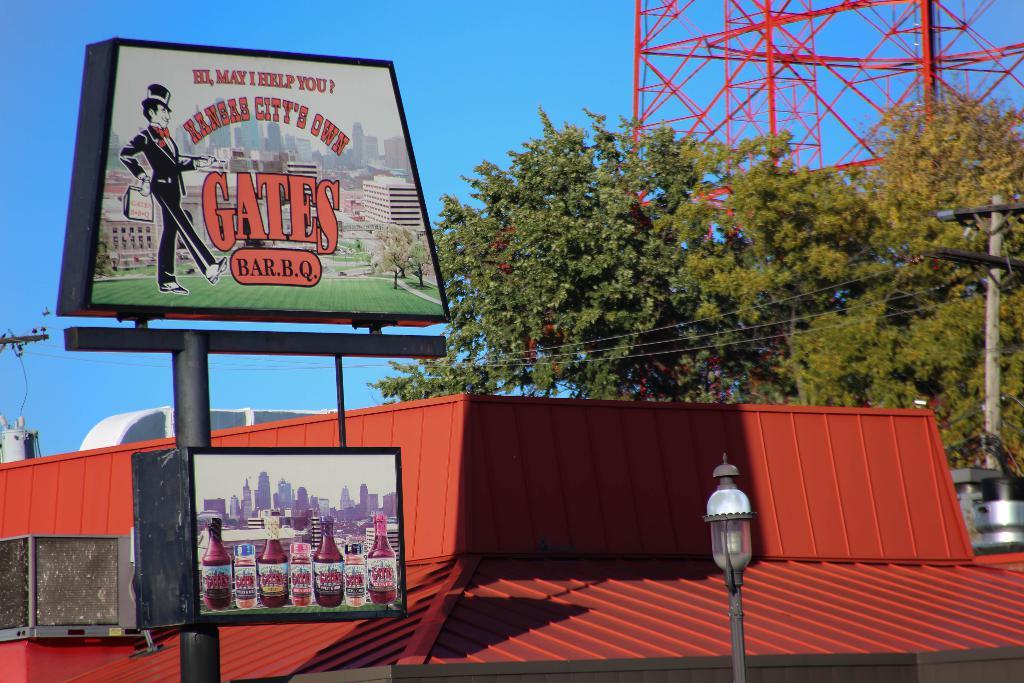Is this bill board for a restaurant?
Offer a very short reply. Yes. 